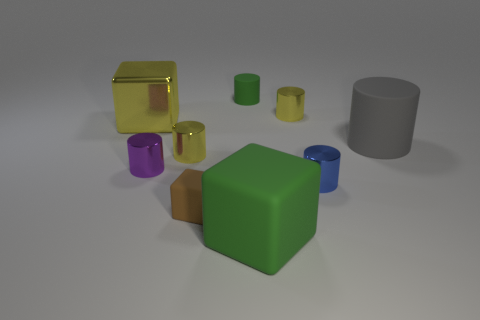Subtract all purple cylinders. How many cylinders are left? 5 Subtract all tiny purple metallic cylinders. How many cylinders are left? 5 Subtract all purple cylinders. Subtract all gray spheres. How many cylinders are left? 5 Add 1 tiny gray metallic cylinders. How many objects exist? 10 Subtract all blocks. How many objects are left? 6 Add 9 big metallic things. How many big metallic things exist? 10 Subtract 1 purple cylinders. How many objects are left? 8 Subtract all large gray rubber objects. Subtract all matte cylinders. How many objects are left? 6 Add 7 small brown matte things. How many small brown matte things are left? 8 